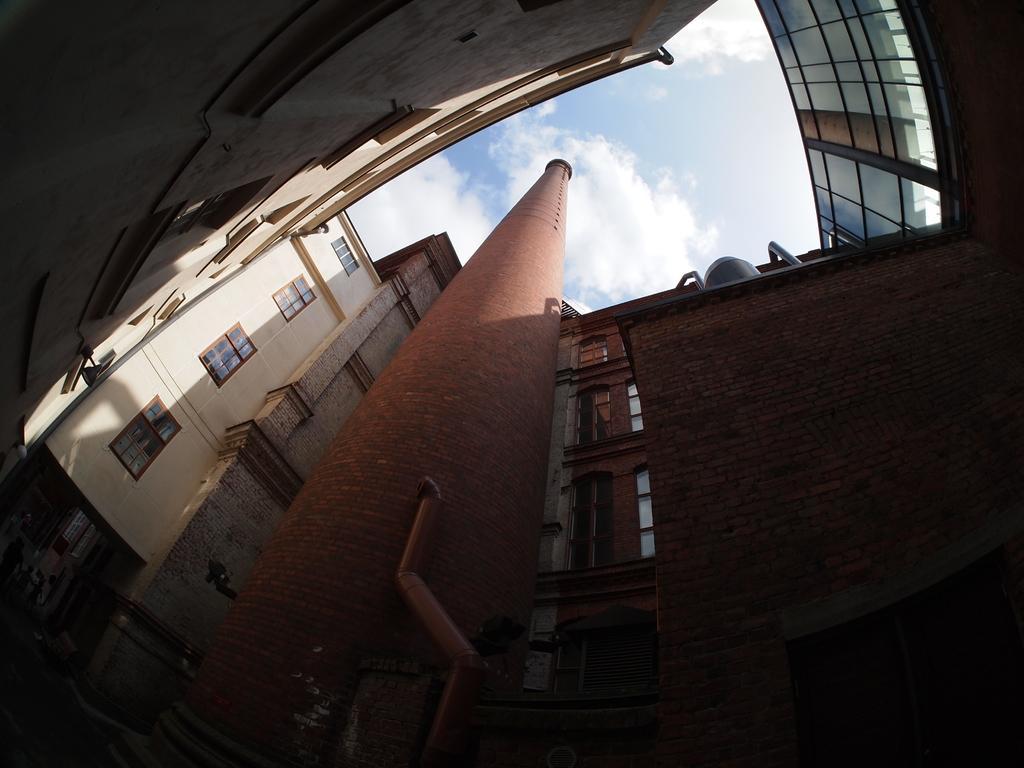In one or two sentences, can you explain what this image depicts? In this image I see buildings on which I see windows and in the background I see the sky which is of white and blue in color and I see a brown color thing over here. 